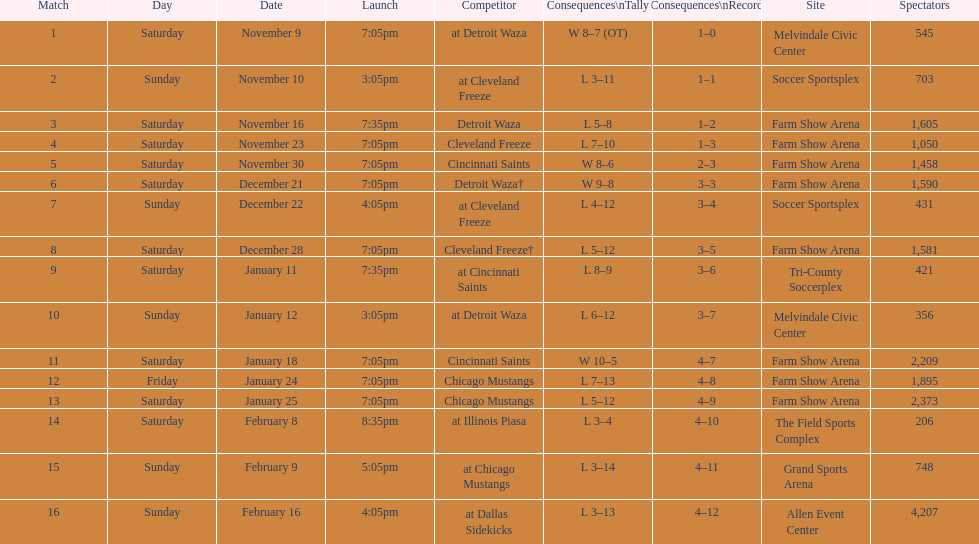Which opponent is listed after cleveland freeze in the table? Detroit Waza. 